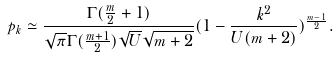<formula> <loc_0><loc_0><loc_500><loc_500>p _ { k } \simeq \frac { \Gamma ( \frac { m } { 2 } + 1 ) } { \sqrt { \pi } \Gamma ( \frac { m + 1 } { 2 } ) \sqrt { U } \sqrt { m + 2 } } ( 1 - \frac { k ^ { 2 } } { U ( m + 2 ) } ) ^ { \frac { m - 1 } { 2 } } .</formula> 